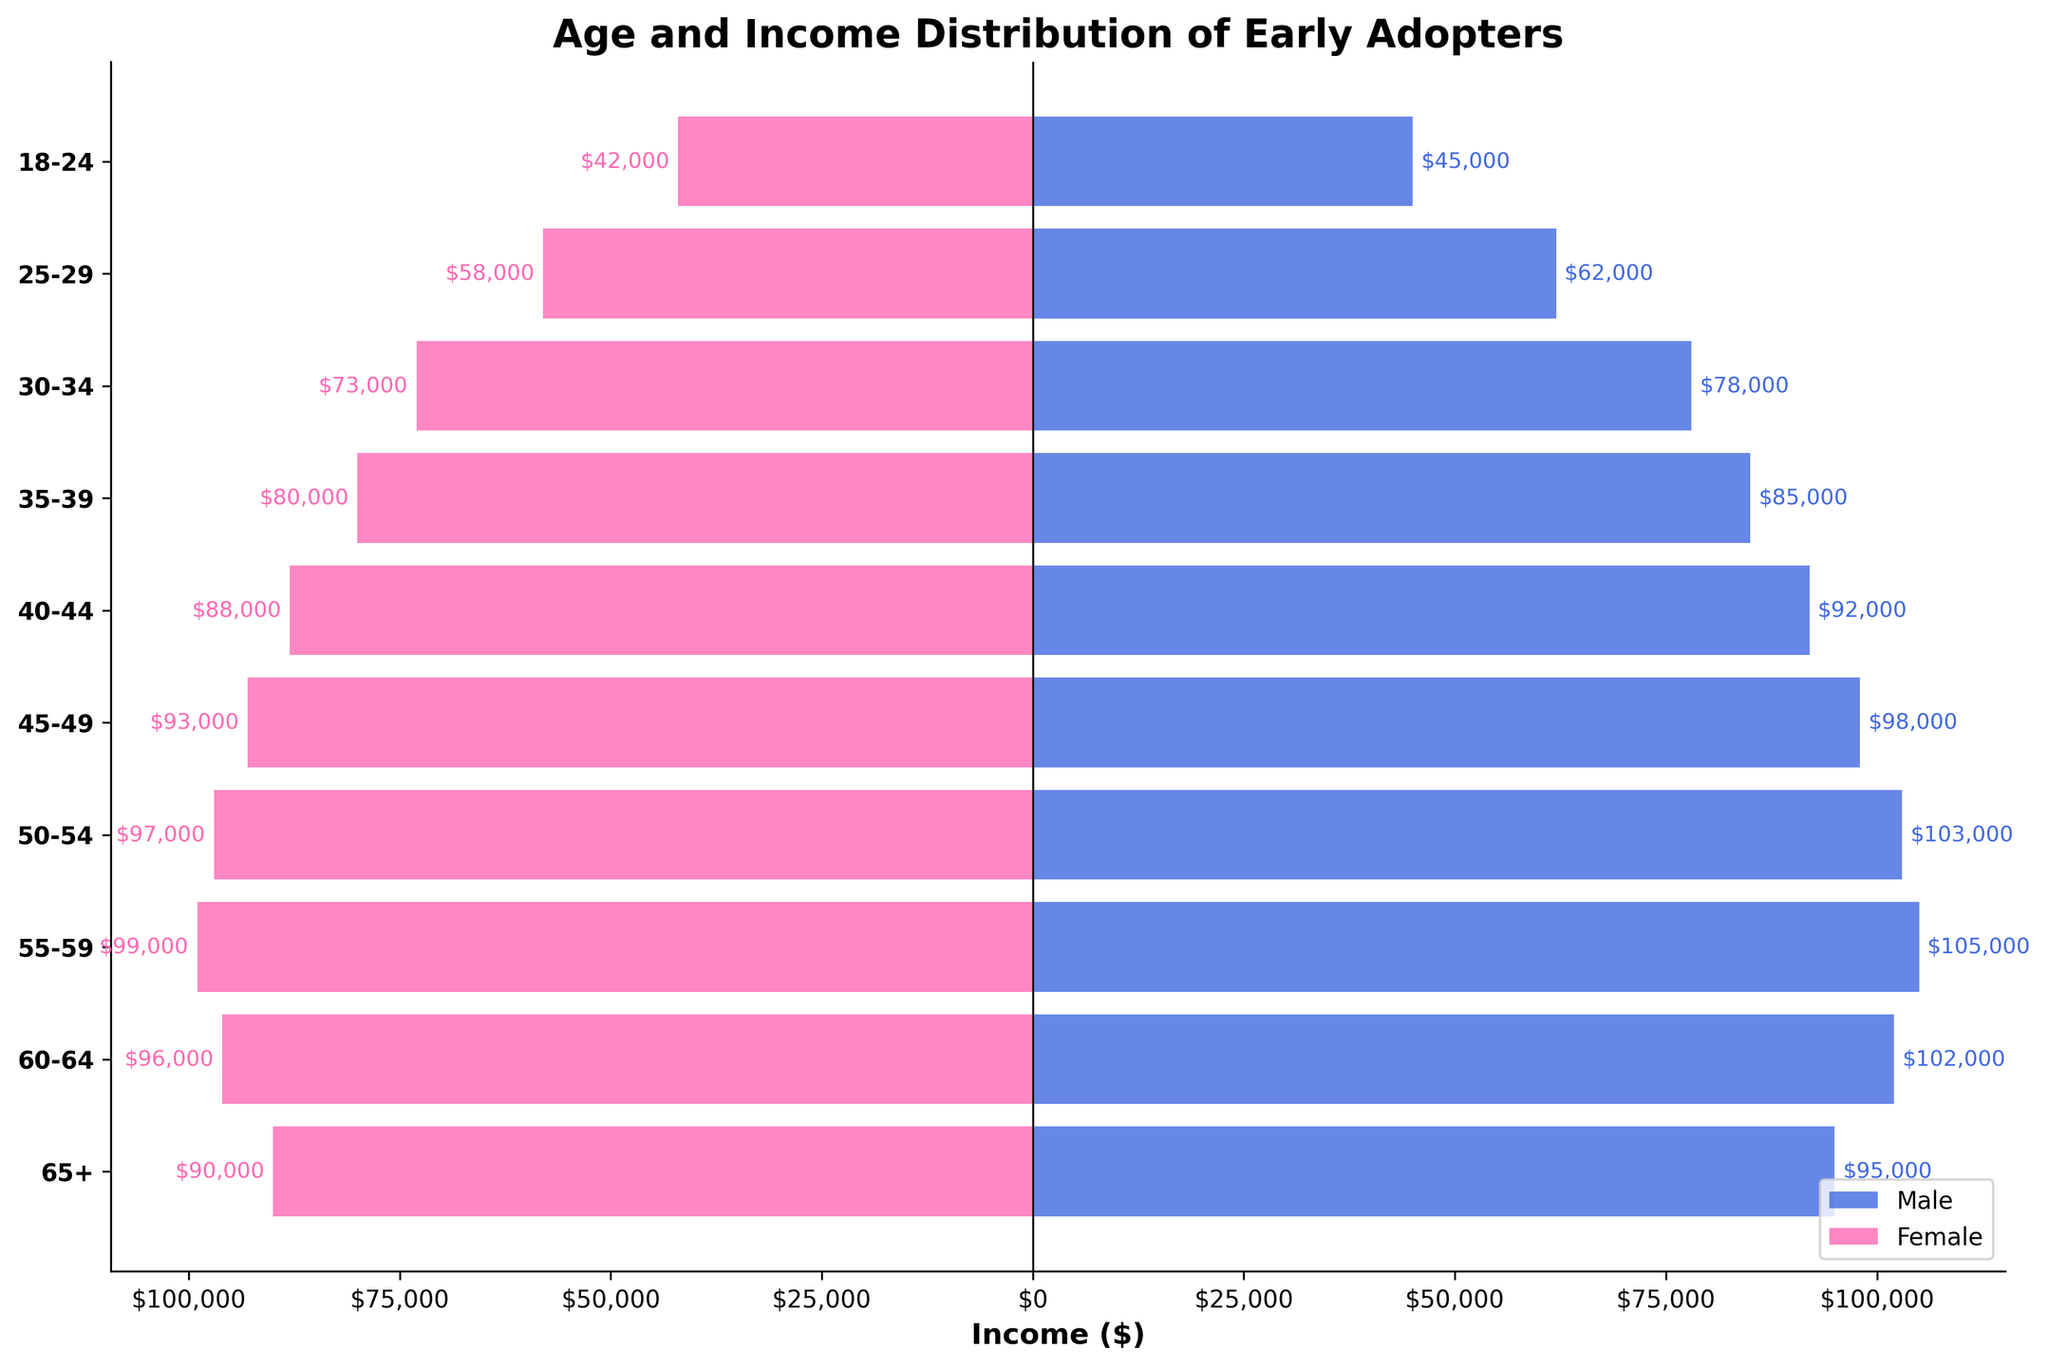What is the title of the figure? Look at the top of the figure where the title is usually located.
Answer: Age and Income Distribution of Early Adopters Which age group has the highest male income? Compare the length of the blue bars for each age group to find the one that extends the farthest.
Answer: 55-59 In which age group is the income difference between males and females the smallest? For each age group, subtract the Female Income from Male Income and find the minimal outcome.
Answer: 55-59 How much more do males aged 45-49 earn compared to females in the same age group? Subtract the income for females from the income for males in the 45-49 age group.
Answer: $5,000 How does the income distribution of females aged 35-39 compare to that of males aged 30-34? Compare the pink bar for females aged 35-39 to the blue bar for males aged 30-34.
Answer: Females aged 35-39 earn $3,000 less than males aged 30-34 Which age group shows the highest female income? Compare the length of the pink bars for each age group.
Answer: 55-59 What is the general trend in income distribution as age increases? Observing the length of bars from the youngest to the oldest age groups, summarize the overall income pattern.
Answer: Income generally increases with age up to 55-59, then starts decreasing What is the total income for males in the age group 18-24 and 25-29 combined? Sum the incomes of males in the 18-24 and 25-29 age groups.
Answer: $107,000 Compare the income gap between genders for the 50-54 and 60-64 age groups. Subtract the female income from the male income for each age group and compare the results.
Answer: The income gap for 50-54 is $6,000 and for 60-64 is $6,000 Which age group has the closest income equality between genders? Identify the smallest difference (absolute value) in income between males and females among all age groups.
Answer: 60-64 